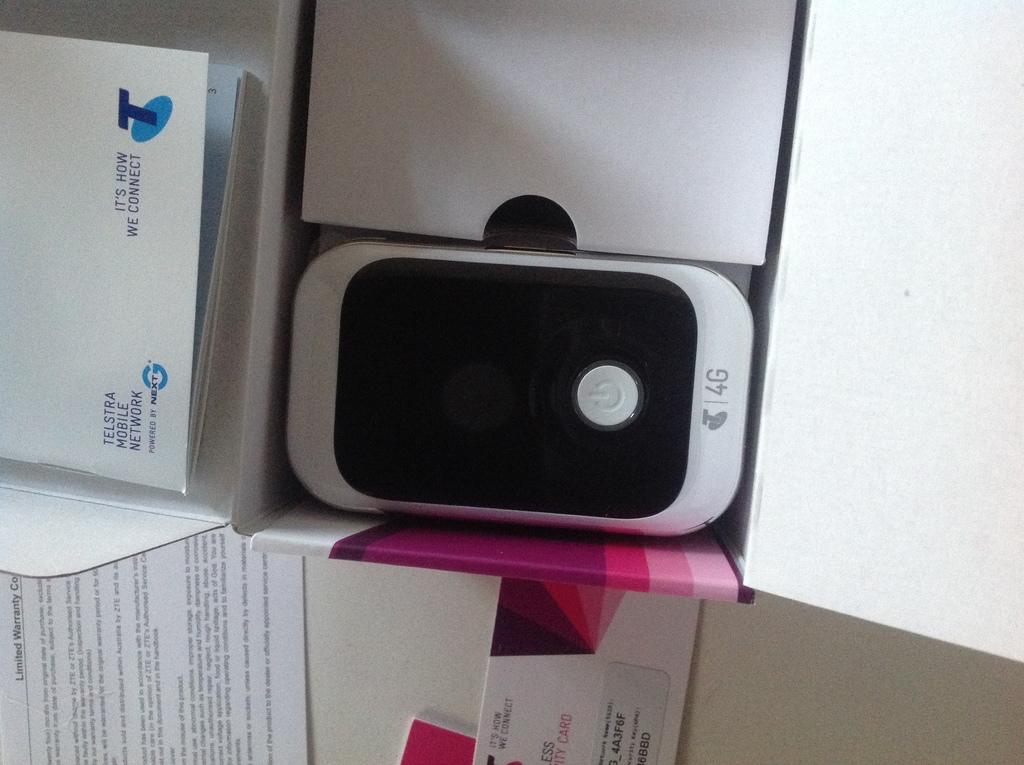Provide a one-sentence caption for the provided image. Telstra mobile network 4g white cellphone in a box. 